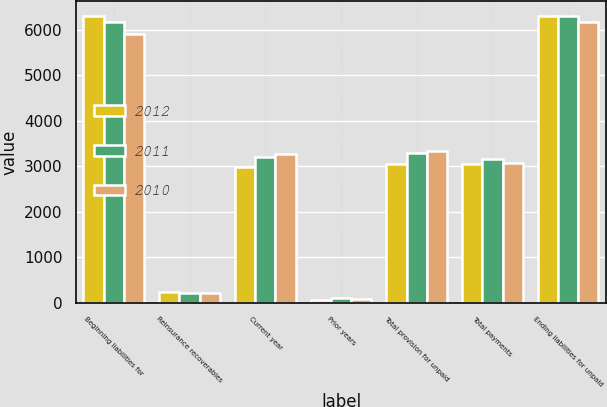Convert chart to OTSL. <chart><loc_0><loc_0><loc_500><loc_500><stacked_bar_chart><ecel><fcel>Beginning liabilities for<fcel>Reinsurance recoverables<fcel>Current year<fcel>Prior years<fcel>Total provision for unpaid<fcel>Total payments<fcel>Ending liabilities for unpaid<nl><fcel>2012<fcel>6314<fcel>233<fcel>2989<fcel>52<fcel>3041<fcel>3060<fcel>6295<nl><fcel>2011<fcel>6179<fcel>209<fcel>3196<fcel>98<fcel>3294<fcel>3159<fcel>6314<nl><fcel>2010<fcel>5918<fcel>213<fcel>3260<fcel>70<fcel>3330<fcel>3069<fcel>6179<nl></chart> 